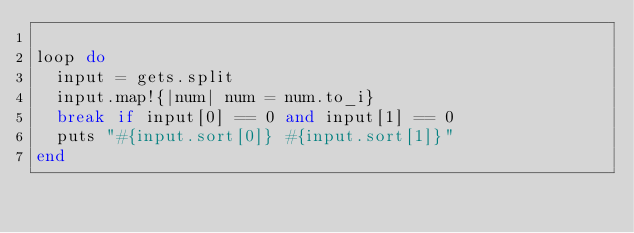Convert code to text. <code><loc_0><loc_0><loc_500><loc_500><_Ruby_>
loop do
  input = gets.split
  input.map!{|num| num = num.to_i}
  break if input[0] == 0 and input[1] == 0
  puts "#{input.sort[0]} #{input.sort[1]}"
end</code> 